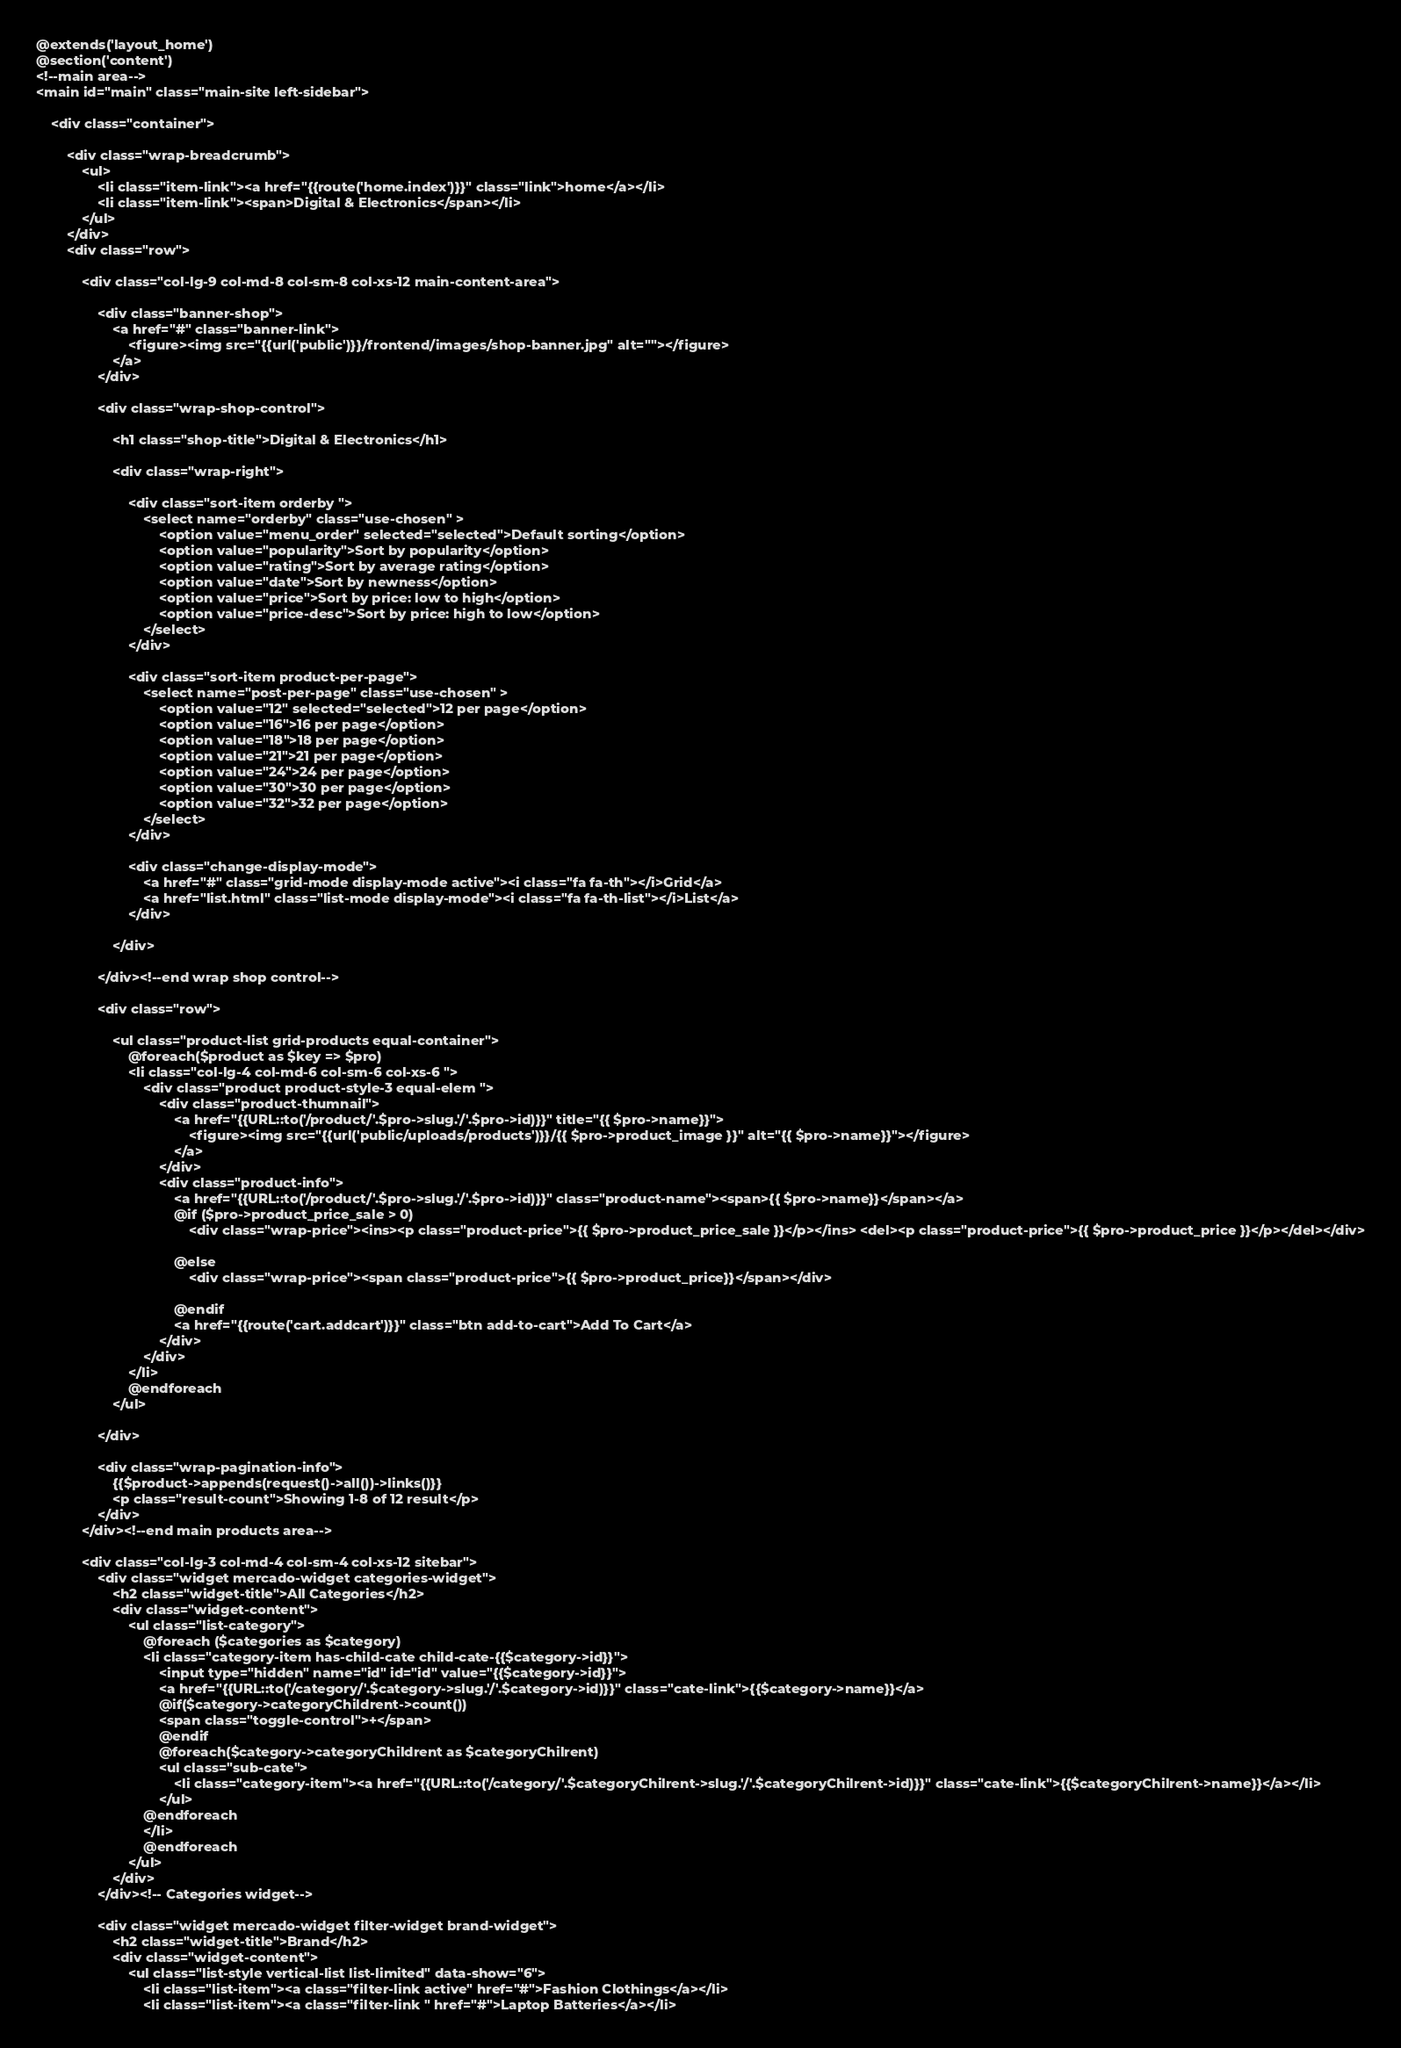<code> <loc_0><loc_0><loc_500><loc_500><_PHP_>@extends('layout_home')
@section('content')
<!--main area-->
<main id="main" class="main-site left-sidebar">

    <div class="container">

        <div class="wrap-breadcrumb">
            <ul>
                <li class="item-link"><a href="{{route('home.index')}}" class="link">home</a></li>
                <li class="item-link"><span>Digital & Electronics</span></li>
            </ul>
        </div>
        <div class="row">

            <div class="col-lg-9 col-md-8 col-sm-8 col-xs-12 main-content-area">

                <div class="banner-shop">
                    <a href="#" class="banner-link">
                        <figure><img src="{{url('public')}}/frontend/images/shop-banner.jpg" alt=""></figure>
                    </a>
                </div>

                <div class="wrap-shop-control">

                    <h1 class="shop-title">Digital & Electronics</h1>

                    <div class="wrap-right">

                        <div class="sort-item orderby ">
                            <select name="orderby" class="use-chosen" >
                                <option value="menu_order" selected="selected">Default sorting</option>
                                <option value="popularity">Sort by popularity</option>
                                <option value="rating">Sort by average rating</option>
                                <option value="date">Sort by newness</option>
                                <option value="price">Sort by price: low to high</option>
                                <option value="price-desc">Sort by price: high to low</option>
                            </select>
                        </div>

                        <div class="sort-item product-per-page">
                            <select name="post-per-page" class="use-chosen" >
                                <option value="12" selected="selected">12 per page</option>
                                <option value="16">16 per page</option>
                                <option value="18">18 per page</option>
                                <option value="21">21 per page</option>
                                <option value="24">24 per page</option>
                                <option value="30">30 per page</option>
                                <option value="32">32 per page</option>
                            </select>
                        </div>

                        <div class="change-display-mode">
                            <a href="#" class="grid-mode display-mode active"><i class="fa fa-th"></i>Grid</a>
                            <a href="list.html" class="list-mode display-mode"><i class="fa fa-th-list"></i>List</a>
                        </div>

                    </div>

                </div><!--end wrap shop control-->

                <div class="row">

                    <ul class="product-list grid-products equal-container">
                        @foreach($product as $key => $pro)
                        <li class="col-lg-4 col-md-6 col-sm-6 col-xs-6 ">
                            <div class="product product-style-3 equal-elem ">
                                <div class="product-thumnail">
                                    <a href="{{URL::to('/product/'.$pro->slug.'/'.$pro->id)}}" title="{{ $pro->name}}">
                                        <figure><img src="{{url('public/uploads/products')}}/{{ $pro->product_image }}" alt="{{ $pro->name}}"></figure>
                                    </a>
                                </div>
                                <div class="product-info">
                                    <a href="{{URL::to('/product/'.$pro->slug.'/'.$pro->id)}}" class="product-name"><span>{{ $pro->name}}</span></a>  
                                    @if ($pro->product_price_sale > 0)
                                        <div class="wrap-price"><ins><p class="product-price">{{ $pro->product_price_sale }}</p></ins> <del><p class="product-price">{{ $pro->product_price }}</p></del></div>
                                    
                                    @else
                                        <div class="wrap-price"><span class="product-price">{{ $pro->product_price}}</span></div>
                                    
                                    @endif
                                    <a href="{{route('cart.addcart')}}" class="btn add-to-cart">Add To Cart</a>
                                </div>
                            </div>
                        </li>
                        @endforeach
                    </ul>

                </div>

                <div class="wrap-pagination-info">
                    {{$product->appends(request()->all())->links()}}
                    <p class="result-count">Showing 1-8 of 12 result</p>
                </div>
            </div><!--end main products area-->

            <div class="col-lg-3 col-md-4 col-sm-4 col-xs-12 sitebar">
                <div class="widget mercado-widget categories-widget">
                    <h2 class="widget-title">All Categories</h2>
                    <div class="widget-content">
                        <ul class="list-category">
                            @foreach ($categories as $category)
                            <li class="category-item has-child-cate child-cate-{{$category->id}}">
                                <input type="hidden" name="id" id="id" value="{{$category->id}}">
                                <a href="{{URL::to('/category/'.$category->slug.'/'.$category->id)}}" class="cate-link">{{$category->name}}</a>
                                @if($category->categoryChildrent->count())
                                <span class="toggle-control">+</span>
                                @endif      
                                @foreach($category->categoryChildrent as $categoryChilrent)
                                <ul class="sub-cate">
                                    <li class="category-item"><a href="{{URL::to('/category/'.$categoryChilrent->slug.'/'.$categoryChilrent->id)}}" class="cate-link">{{$categoryChilrent->name}}</a></li>
                                </ul>                                     
                            @endforeach                    
                            </li>
                            @endforeach
                        </ul>
                    </div>
                </div><!-- Categories widget-->

                <div class="widget mercado-widget filter-widget brand-widget">
                    <h2 class="widget-title">Brand</h2>
                    <div class="widget-content">
                        <ul class="list-style vertical-list list-limited" data-show="6">
                            <li class="list-item"><a class="filter-link active" href="#">Fashion Clothings</a></li>
                            <li class="list-item"><a class="filter-link " href="#">Laptop Batteries</a></li></code> 